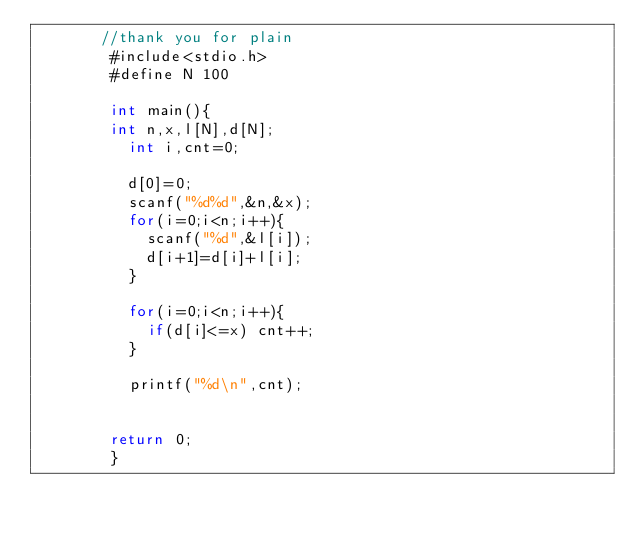Convert code to text. <code><loc_0><loc_0><loc_500><loc_500><_C_>       //thank you for plain
        #include<stdio.h>
        #define N 100
         
        int main(){
        int n,x,l[N],d[N];
          int i,cnt=0;
          
          d[0]=0;
          scanf("%d%d",&n,&x);
          for(i=0;i<n;i++){
            scanf("%d",&l[i]);
            d[i+1]=d[i]+l[i];
          }
          
          for(i=0;i<n;i++){
            if(d[i]<=x) cnt++;
          }
          
          printf("%d\n",cnt);
         
         
        return 0;
        }</code> 